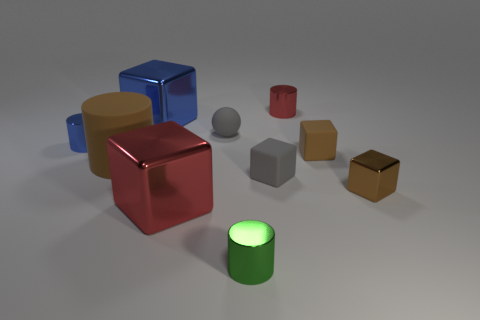Subtract all green cylinders. How many cylinders are left? 3 Subtract all red cubes. How many cubes are left? 4 Subtract 2 cylinders. How many cylinders are left? 2 Subtract all brown cylinders. How many brown blocks are left? 2 Subtract all cylinders. How many objects are left? 6 Subtract all red cubes. Subtract all purple balls. How many cubes are left? 4 Subtract all blue metallic blocks. Subtract all rubber cylinders. How many objects are left? 8 Add 6 tiny gray matte spheres. How many tiny gray matte spheres are left? 7 Add 6 small brown cubes. How many small brown cubes exist? 8 Subtract 1 green cylinders. How many objects are left? 9 